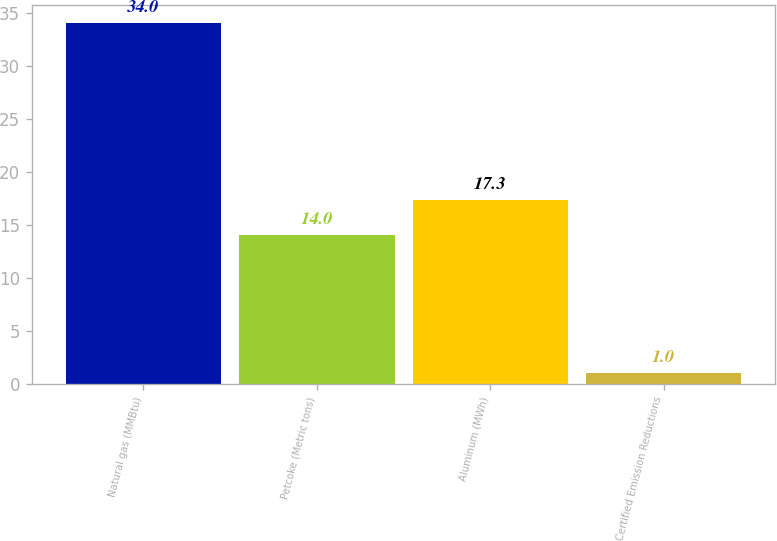<chart> <loc_0><loc_0><loc_500><loc_500><bar_chart><fcel>Natural gas (MMBtu)<fcel>Petcoke (Metric tons)<fcel>Aluminum (MWh)<fcel>Certified Emission Reductions<nl><fcel>34<fcel>14<fcel>17.3<fcel>1<nl></chart> 